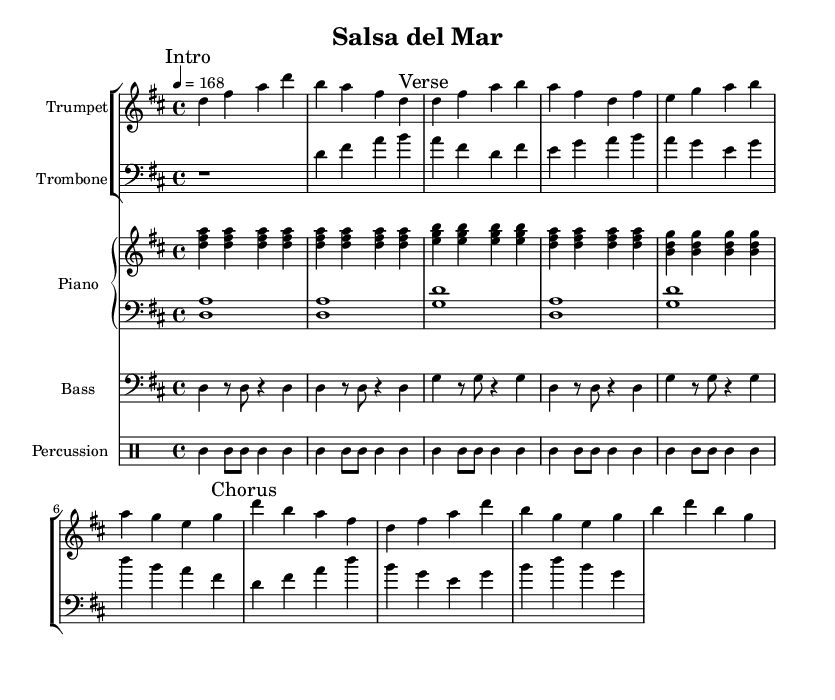What is the time signature of this music? The time signature is indicated as 4/4, which means there are four beats in each measure and the quarter note gets one beat.
Answer: 4/4 What is the key signature of this music? The key signature shows two sharps (F# and C#), indicating that the music is in D major.
Answer: D major What is the tempo marking for this piece? The tempo marking is indicated as 4 = 168, meaning there are 168 beats per minute.
Answer: 168 How many measures are in the Trumpet section? By counting the measures in the Trumpet music, there are a total of four measures in both the Intro and Verse, and the Chorus also contains four measures, totaling twelve measures overall.
Answer: 12 Which instruments are included in the score? The score includes Trumpet, Trombone, Piano (with right-hand and left-hand parts), Bass, and Percussion.
Answer: Trumpet, Trombone, Piano, Bass, Percussion What is the rhythmic pattern used in the drum section? The rhythmic pattern is represented by the "cl" (clap) symbol, which consistently shows a pattern of quarter and eighth notes played throughout, providing an upbeat feel typical of salsa.
Answer: Clap What is the chord structure in the Piano's right hand during the Intro? The chord structure in the Piano's right hand during the Intro consists of three notes played in unison, specifically D, F#, and A, forming a D major chord.
Answer: D, F#, A 